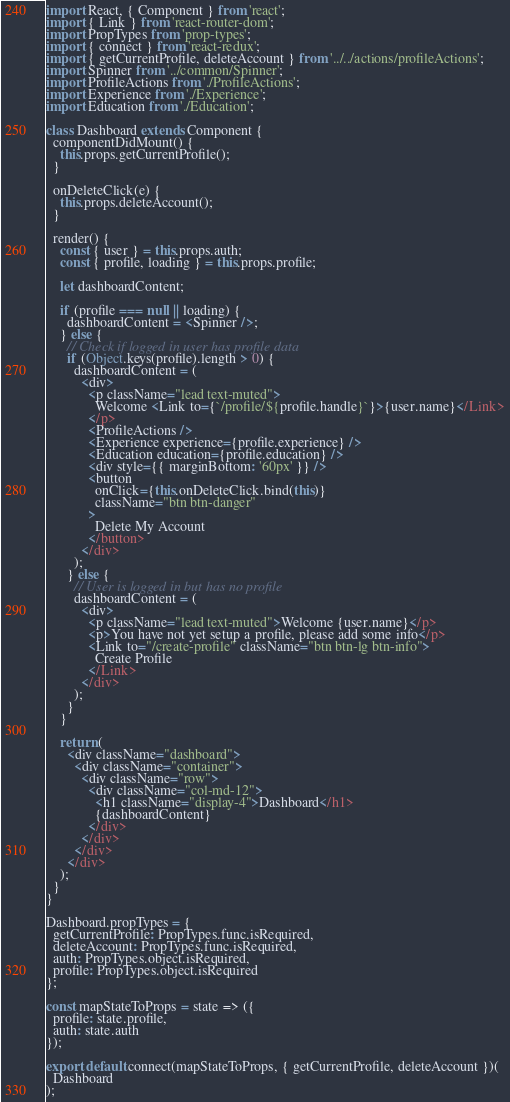<code> <loc_0><loc_0><loc_500><loc_500><_JavaScript_>import React, { Component } from 'react';
import { Link } from 'react-router-dom';
import PropTypes from 'prop-types';
import { connect } from 'react-redux';
import { getCurrentProfile, deleteAccount } from '../../actions/profileActions';
import Spinner from '../common/Spinner';
import ProfileActions from './ProfileActions';
import Experience from './Experience';
import Education from './Education';

class Dashboard extends Component {
  componentDidMount() {
    this.props.getCurrentProfile();
  }

  onDeleteClick(e) {
    this.props.deleteAccount();
  }

  render() {
    const { user } = this.props.auth;
    const { profile, loading } = this.props.profile;

    let dashboardContent;

    if (profile === null || loading) {
      dashboardContent = <Spinner />;
    } else {
      // Check if logged in user has profile data
      if (Object.keys(profile).length > 0) {
        dashboardContent = (
          <div>
            <p className="lead text-muted">
              Welcome <Link to={`/profile/${profile.handle}`}>{user.name}</Link>
            </p>
            <ProfileActions />
            <Experience experience={profile.experience} />
            <Education education={profile.education} />
            <div style={{ marginBottom: '60px' }} />
            <button
              onClick={this.onDeleteClick.bind(this)}
              className="btn btn-danger"
            >
              Delete My Account
            </button>
          </div>
        );
      } else {
        // User is logged in but has no profile
        dashboardContent = (
          <div>
            <p className="lead text-muted">Welcome {user.name}</p>
            <p>You have not yet setup a profile, please add some info</p>
            <Link to="/create-profile" className="btn btn-lg btn-info">
              Create Profile
            </Link>
          </div>
        );
      }
    }

    return (
      <div className="dashboard">
        <div className="container">
          <div className="row">
            <div className="col-md-12">
              <h1 className="display-4">Dashboard</h1>
              {dashboardContent}
            </div>
          </div>
        </div>
      </div>
    );
  }
}

Dashboard.propTypes = {
  getCurrentProfile: PropTypes.func.isRequired,
  deleteAccount: PropTypes.func.isRequired,
  auth: PropTypes.object.isRequired,
  profile: PropTypes.object.isRequired
};

const mapStateToProps = state => ({
  profile: state.profile,
  auth: state.auth
});

export default connect(mapStateToProps, { getCurrentProfile, deleteAccount })(
  Dashboard
);
</code> 